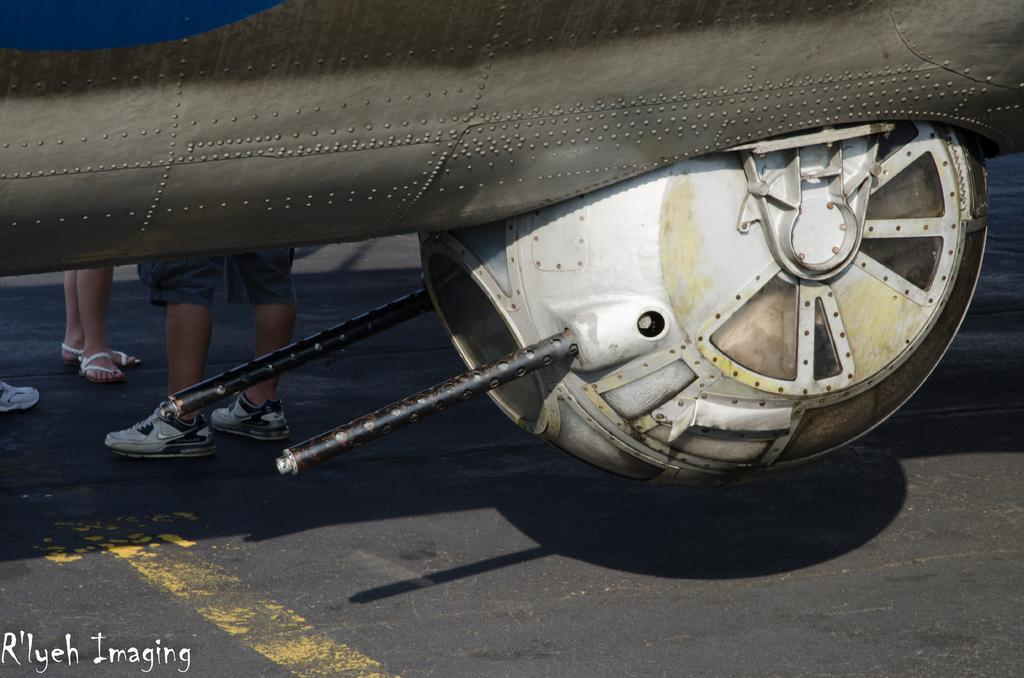What is the main subject of the image? There is a vehicle in the image. Can you describe the people in the image? There are people standing behind the vehicle. What type of crack is visible on the vehicle in the image? There is no crack visible on the vehicle in the image. How many groups of people are standing behind the vehicle in the image? There is no mention of multiple groups of people in the image; only people are mentioned. 